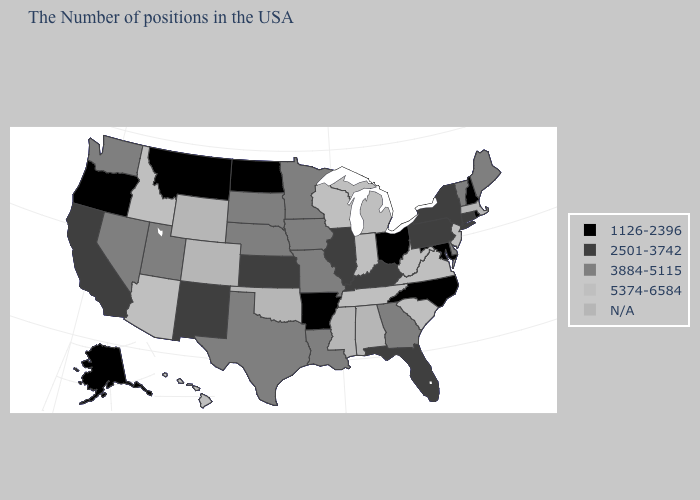Which states hav the highest value in the MidWest?
Be succinct. Michigan, Indiana, Wisconsin. Name the states that have a value in the range 2501-3742?
Be succinct. Connecticut, New York, Pennsylvania, Florida, Kentucky, Illinois, Kansas, New Mexico, California. Which states hav the highest value in the MidWest?
Short answer required. Michigan, Indiana, Wisconsin. Does the first symbol in the legend represent the smallest category?
Give a very brief answer. Yes. Which states have the lowest value in the USA?
Keep it brief. Rhode Island, New Hampshire, Maryland, North Carolina, Ohio, Arkansas, North Dakota, Montana, Oregon, Alaska. What is the lowest value in states that border North Carolina?
Give a very brief answer. 3884-5115. Which states have the lowest value in the South?
Give a very brief answer. Maryland, North Carolina, Arkansas. Name the states that have a value in the range 1126-2396?
Short answer required. Rhode Island, New Hampshire, Maryland, North Carolina, Ohio, Arkansas, North Dakota, Montana, Oregon, Alaska. Does the map have missing data?
Short answer required. Yes. Name the states that have a value in the range 3884-5115?
Concise answer only. Maine, Vermont, Delaware, Georgia, Louisiana, Missouri, Minnesota, Iowa, Nebraska, Texas, South Dakota, Utah, Nevada, Washington. Name the states that have a value in the range 5374-6584?
Give a very brief answer. New Jersey, Virginia, South Carolina, West Virginia, Michigan, Indiana, Tennessee, Wisconsin, Arizona, Idaho, Hawaii. What is the value of Kentucky?
Short answer required. 2501-3742. Does the map have missing data?
Write a very short answer. Yes. Name the states that have a value in the range 2501-3742?
Answer briefly. Connecticut, New York, Pennsylvania, Florida, Kentucky, Illinois, Kansas, New Mexico, California. Does Arkansas have the lowest value in the South?
Answer briefly. Yes. 